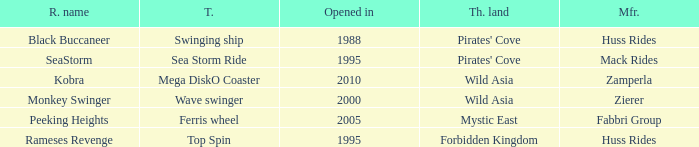What type of ride is Rameses Revenge? Top Spin. 